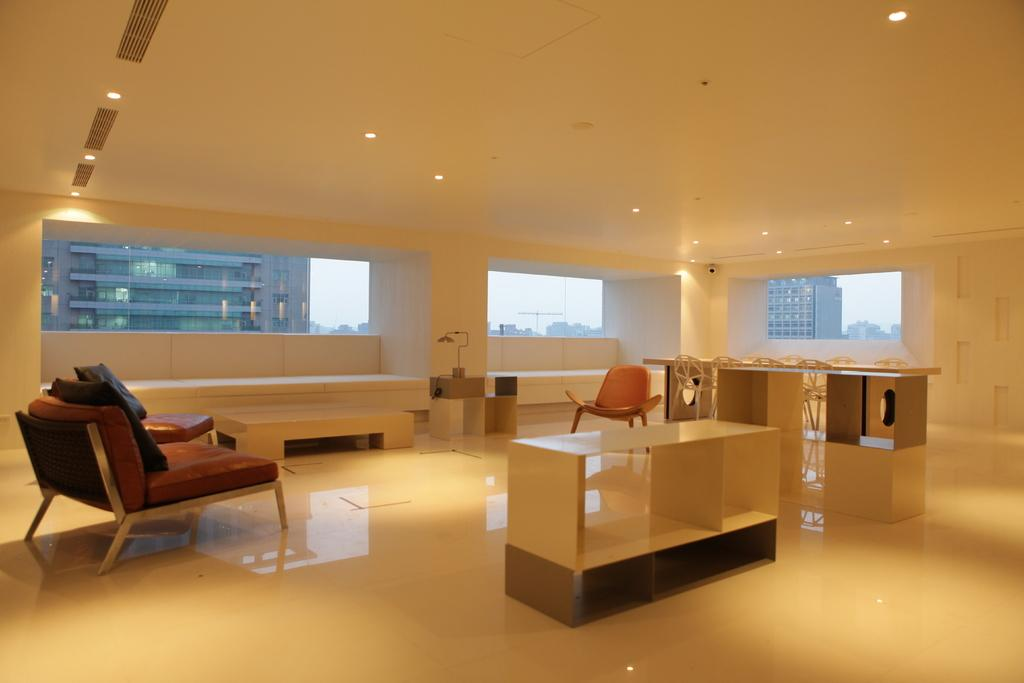What part of the room can be seen in the image? The ceiling, floor, and platforms are visible in the image. What type of lighting is present in the image? Lights are visible in the image. What type of windows are in the room? There are glass windows in the image. What type of furniture is present in the image? Chairs are present in the image. What other objects can be seen in the image? There are air ducts and other objects visible in the image. How many cows are visible in the image? There are no cows present in the image. What level of expertise is required to use the note in the image? There is no note present in the image, so it cannot be determined what level of expertise is required. 